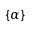Convert formula to latex. <formula><loc_0><loc_0><loc_500><loc_500>\{ \alpha \}</formula> 